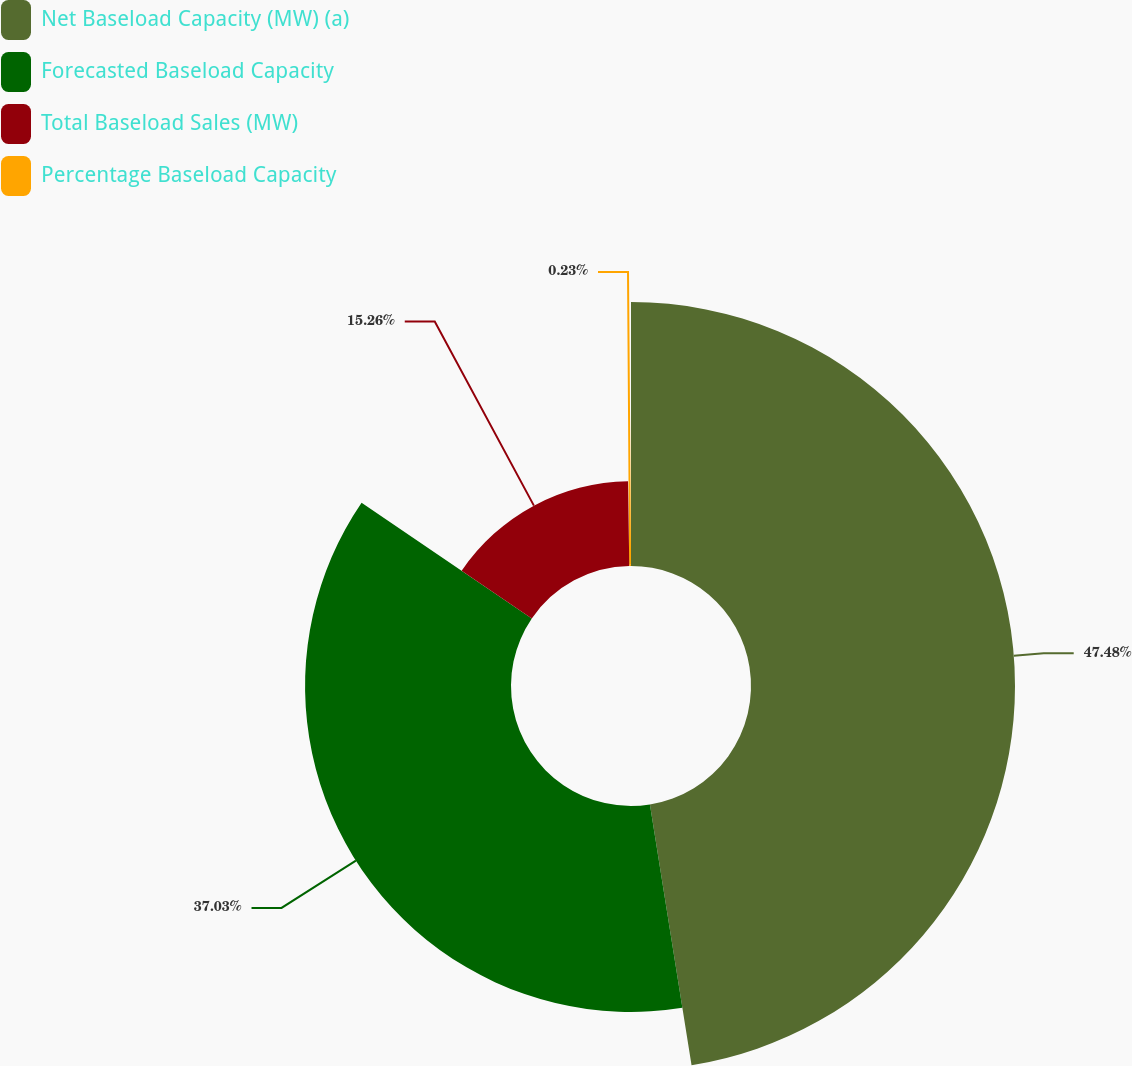Convert chart. <chart><loc_0><loc_0><loc_500><loc_500><pie_chart><fcel>Net Baseload Capacity (MW) (a)<fcel>Forecasted Baseload Capacity<fcel>Total Baseload Sales (MW)<fcel>Percentage Baseload Capacity<nl><fcel>47.48%<fcel>37.03%<fcel>15.26%<fcel>0.23%<nl></chart> 